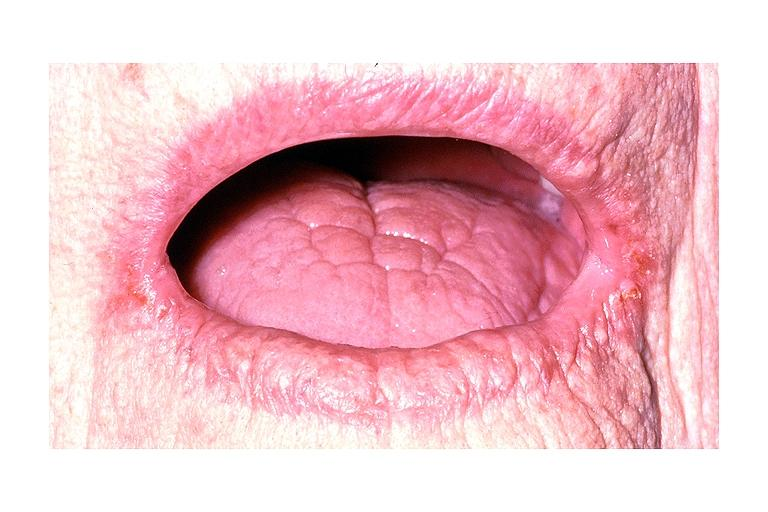what is present?
Answer the question using a single word or phrase. Oral 